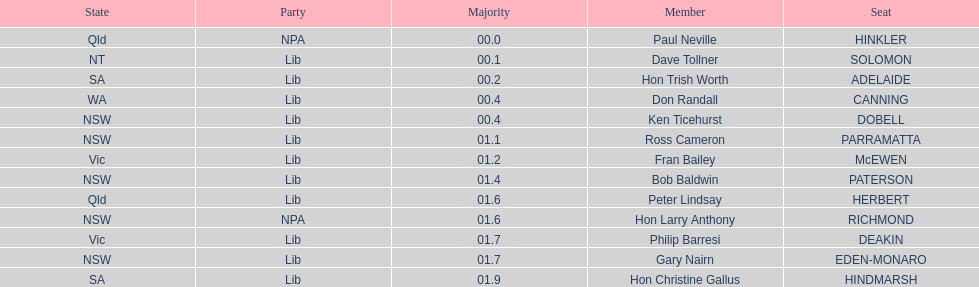Was fran bailey from vic or wa? Vic. 